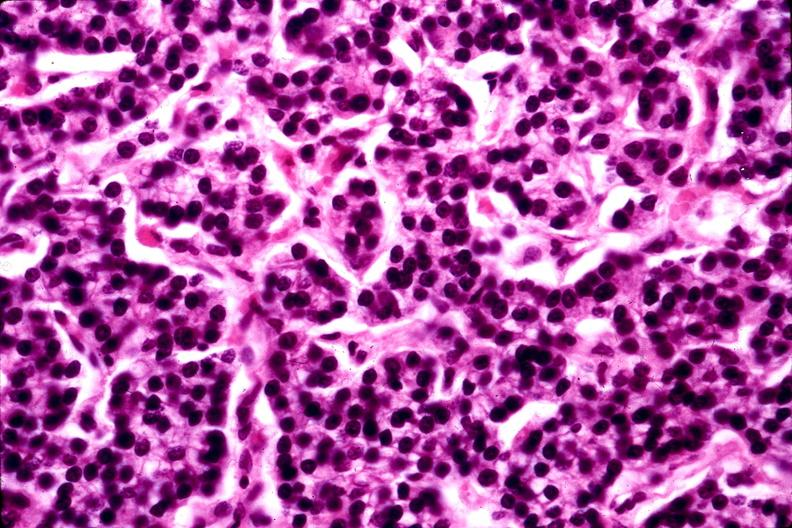where is this part in the figure?
Answer the question using a single word or phrase. Endocrine system 